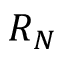Convert formula to latex. <formula><loc_0><loc_0><loc_500><loc_500>R _ { N }</formula> 